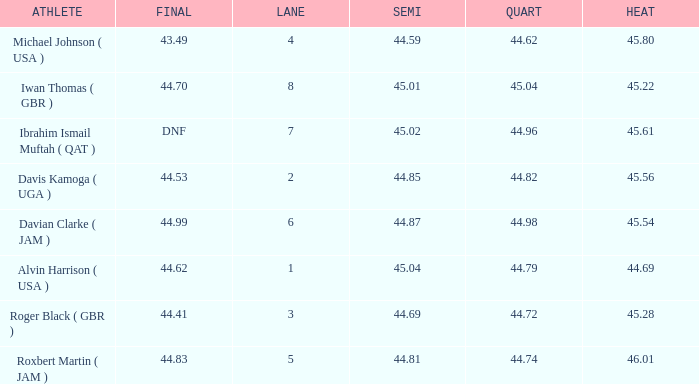When a lane of 4 has a QUART greater than 44.62, what is the lowest HEAT? None. 